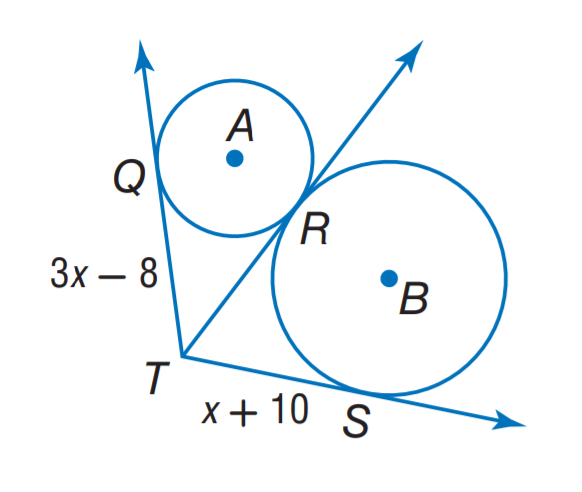Question: The segment is tangent to the circle. Find x.
Choices:
A. 7
B. 8
C. 9
D. 10
Answer with the letter. Answer: C 